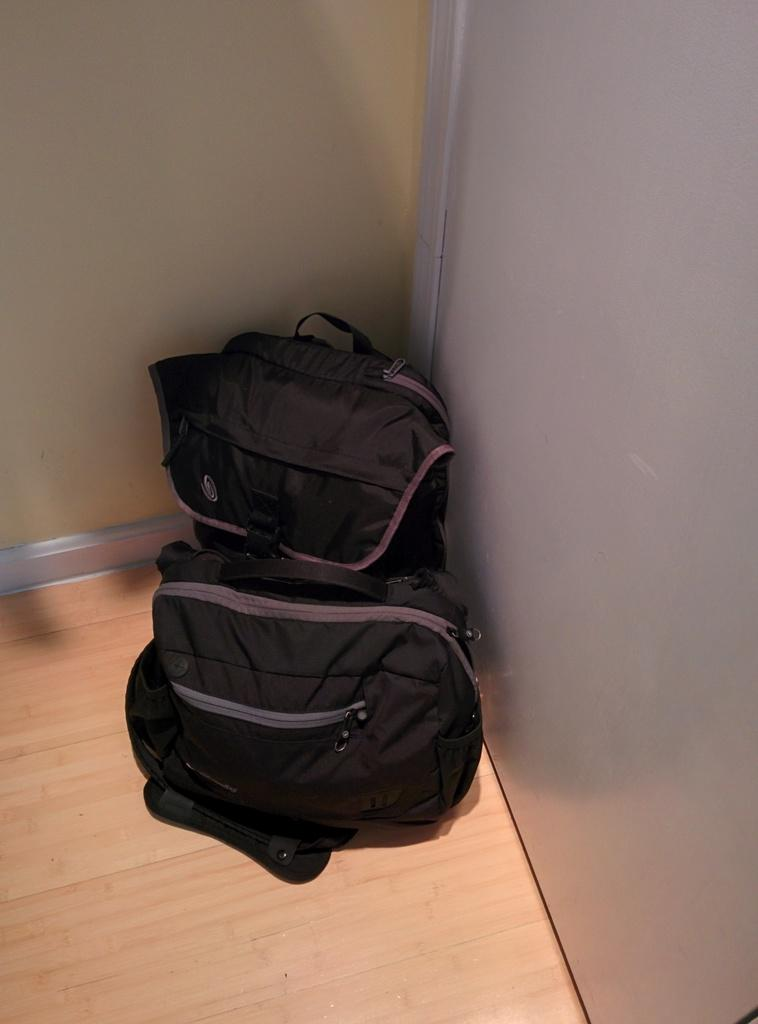What objects can be seen in the image? There are bags in the image. What type of flooring is visible in the image? There is a wooden floor in the image. What surrounds the space in the image? There are walls in the image. Where is the nest located in the image? There is no nest present in the image. What type of wilderness can be seen through the window in the image? There is no window or wilderness present in the image. 